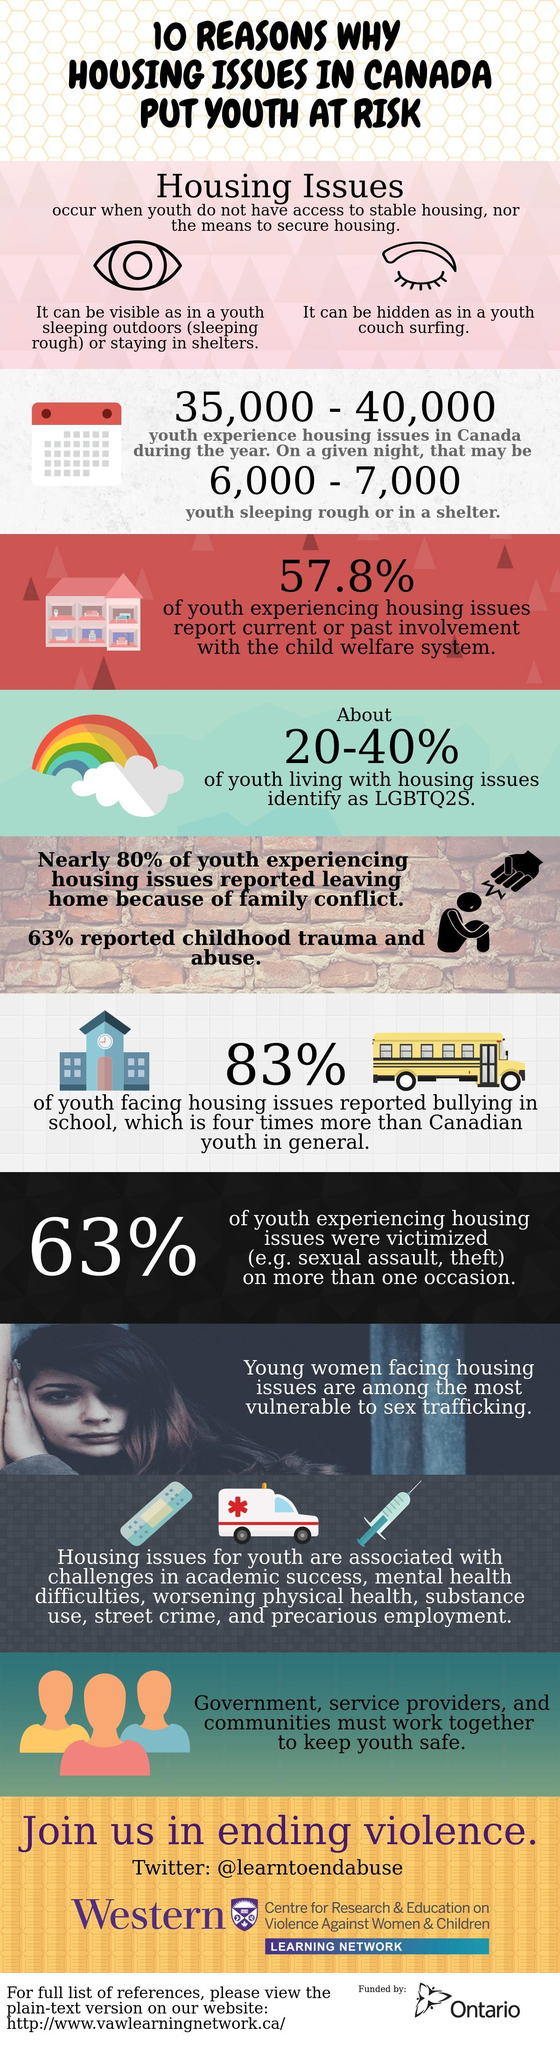What percentage of Youth in Canada have housing issues and are LGBTQ2S?
Answer the question with a short phrase. 20-40% What percentage of Youth in Canada are leaving home due to parents conflict? 80% What percentage of Youth in Canada have housing issues and faced bullying in school? 83% 